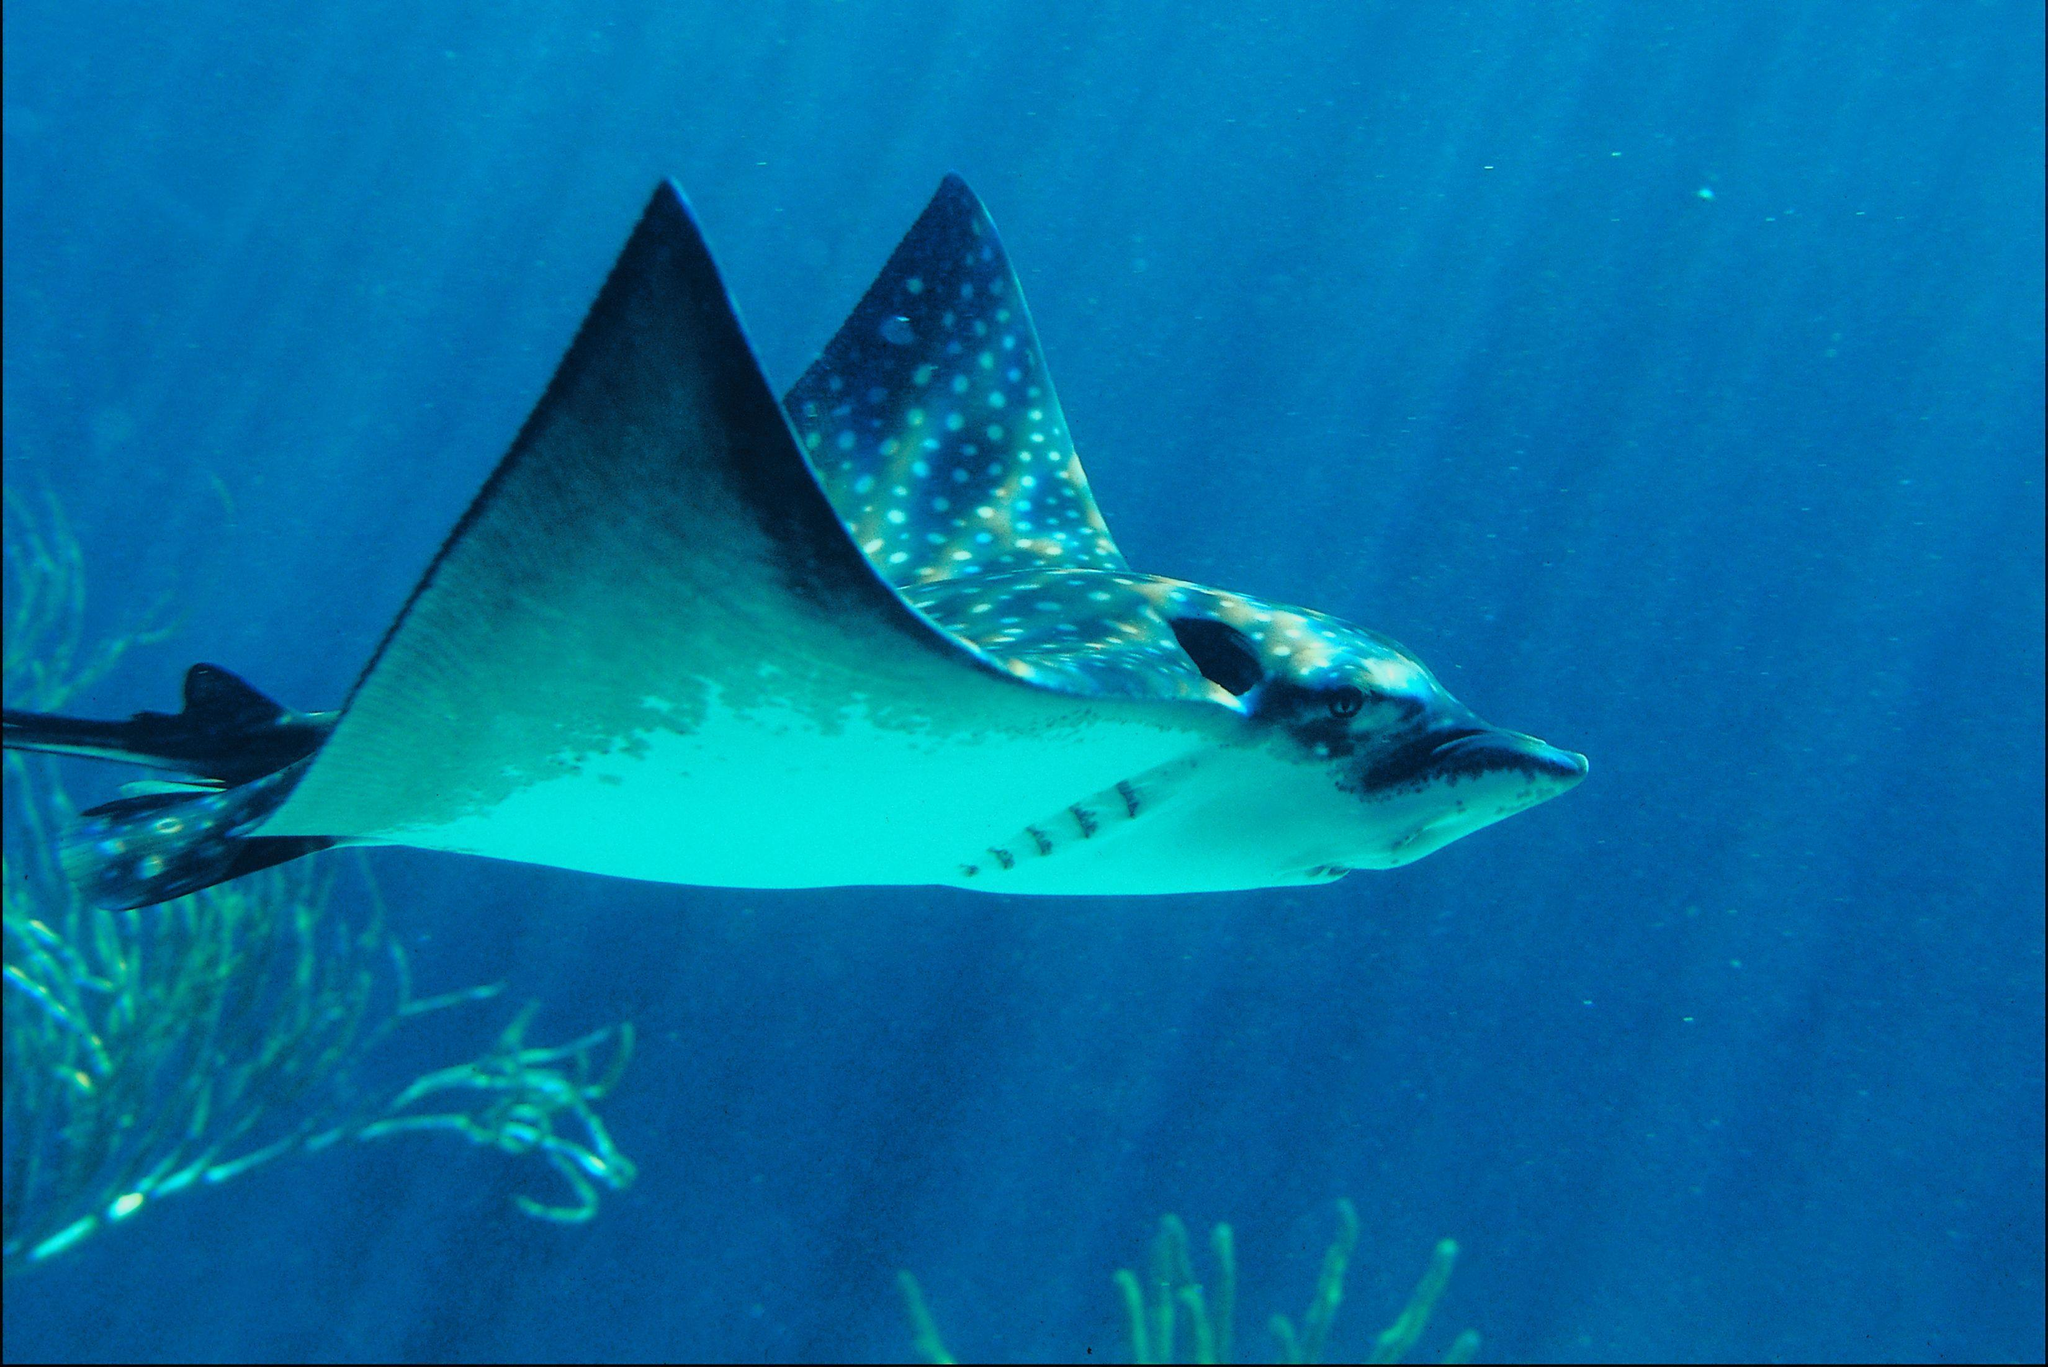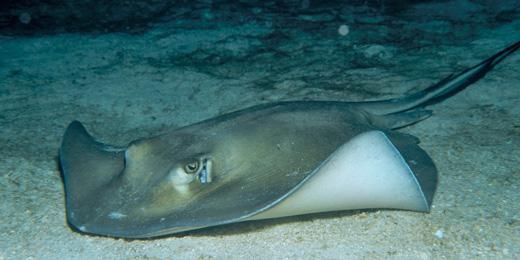The first image is the image on the left, the second image is the image on the right. Assess this claim about the two images: "There is one spotted eagle ray.". Correct or not? Answer yes or no. Yes. The first image is the image on the left, the second image is the image on the right. For the images displayed, is the sentence "There are two stingrays and no other creatures." factually correct? Answer yes or no. Yes. 